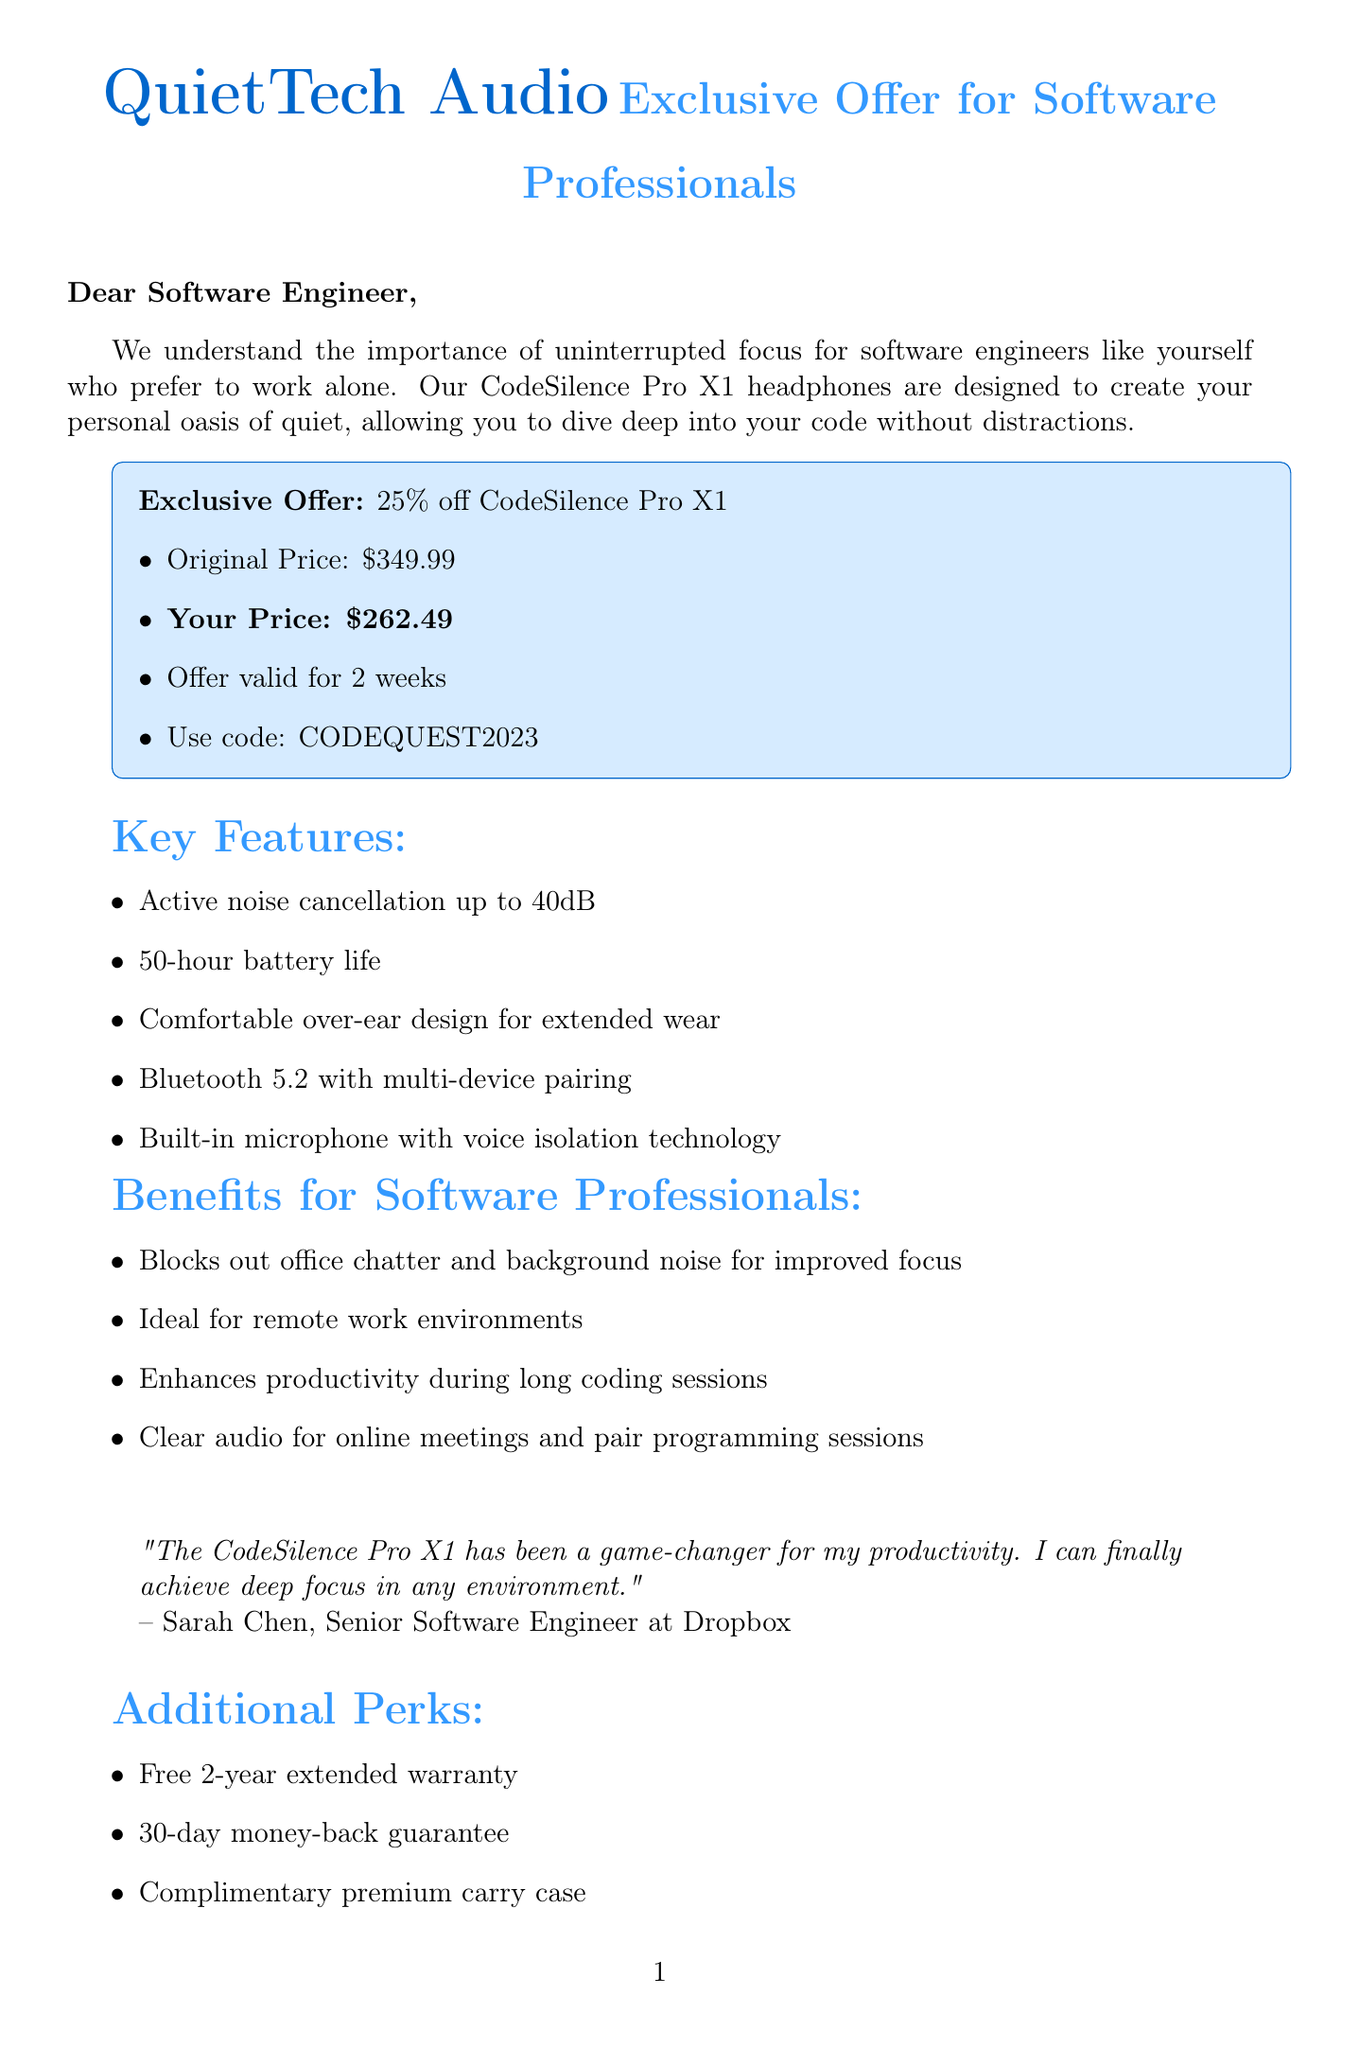What is the product name? The document mentions the product name, which is the CodeSilence Pro X1.
Answer: CodeSilence Pro X1 What is the discount percentage? The document indicates that the discount offered is 25 percent.
Answer: 25% What is the original price of the headphones? The original price listed for the CodeSilence Pro X1 is $349.99.
Answer: $349.99 How long is the offer valid? The document states that the offer is valid for 2 weeks.
Answer: 2 weeks What is the exclusive offer code? The document specifies the exclusive offer code as CODEQUEST2023.
Answer: CODEQUEST2023 What audio feature enhances productivity during long coding sessions? The document mentions blocking out office chatter and background noise as a benefit for improved focus.
Answer: Blocks out office chatter and background noise Who provided the testimonial? The document cites Sarah Chen as the person who provided the testimonial.
Answer: Sarah Chen What is included in the additional perks? The document lists a free 2-year extended warranty as one of the additional perks.
Answer: Free 2-year extended warranty What are the customer support hours? The document states that customer support is available 24/7.
Answer: 24/7 